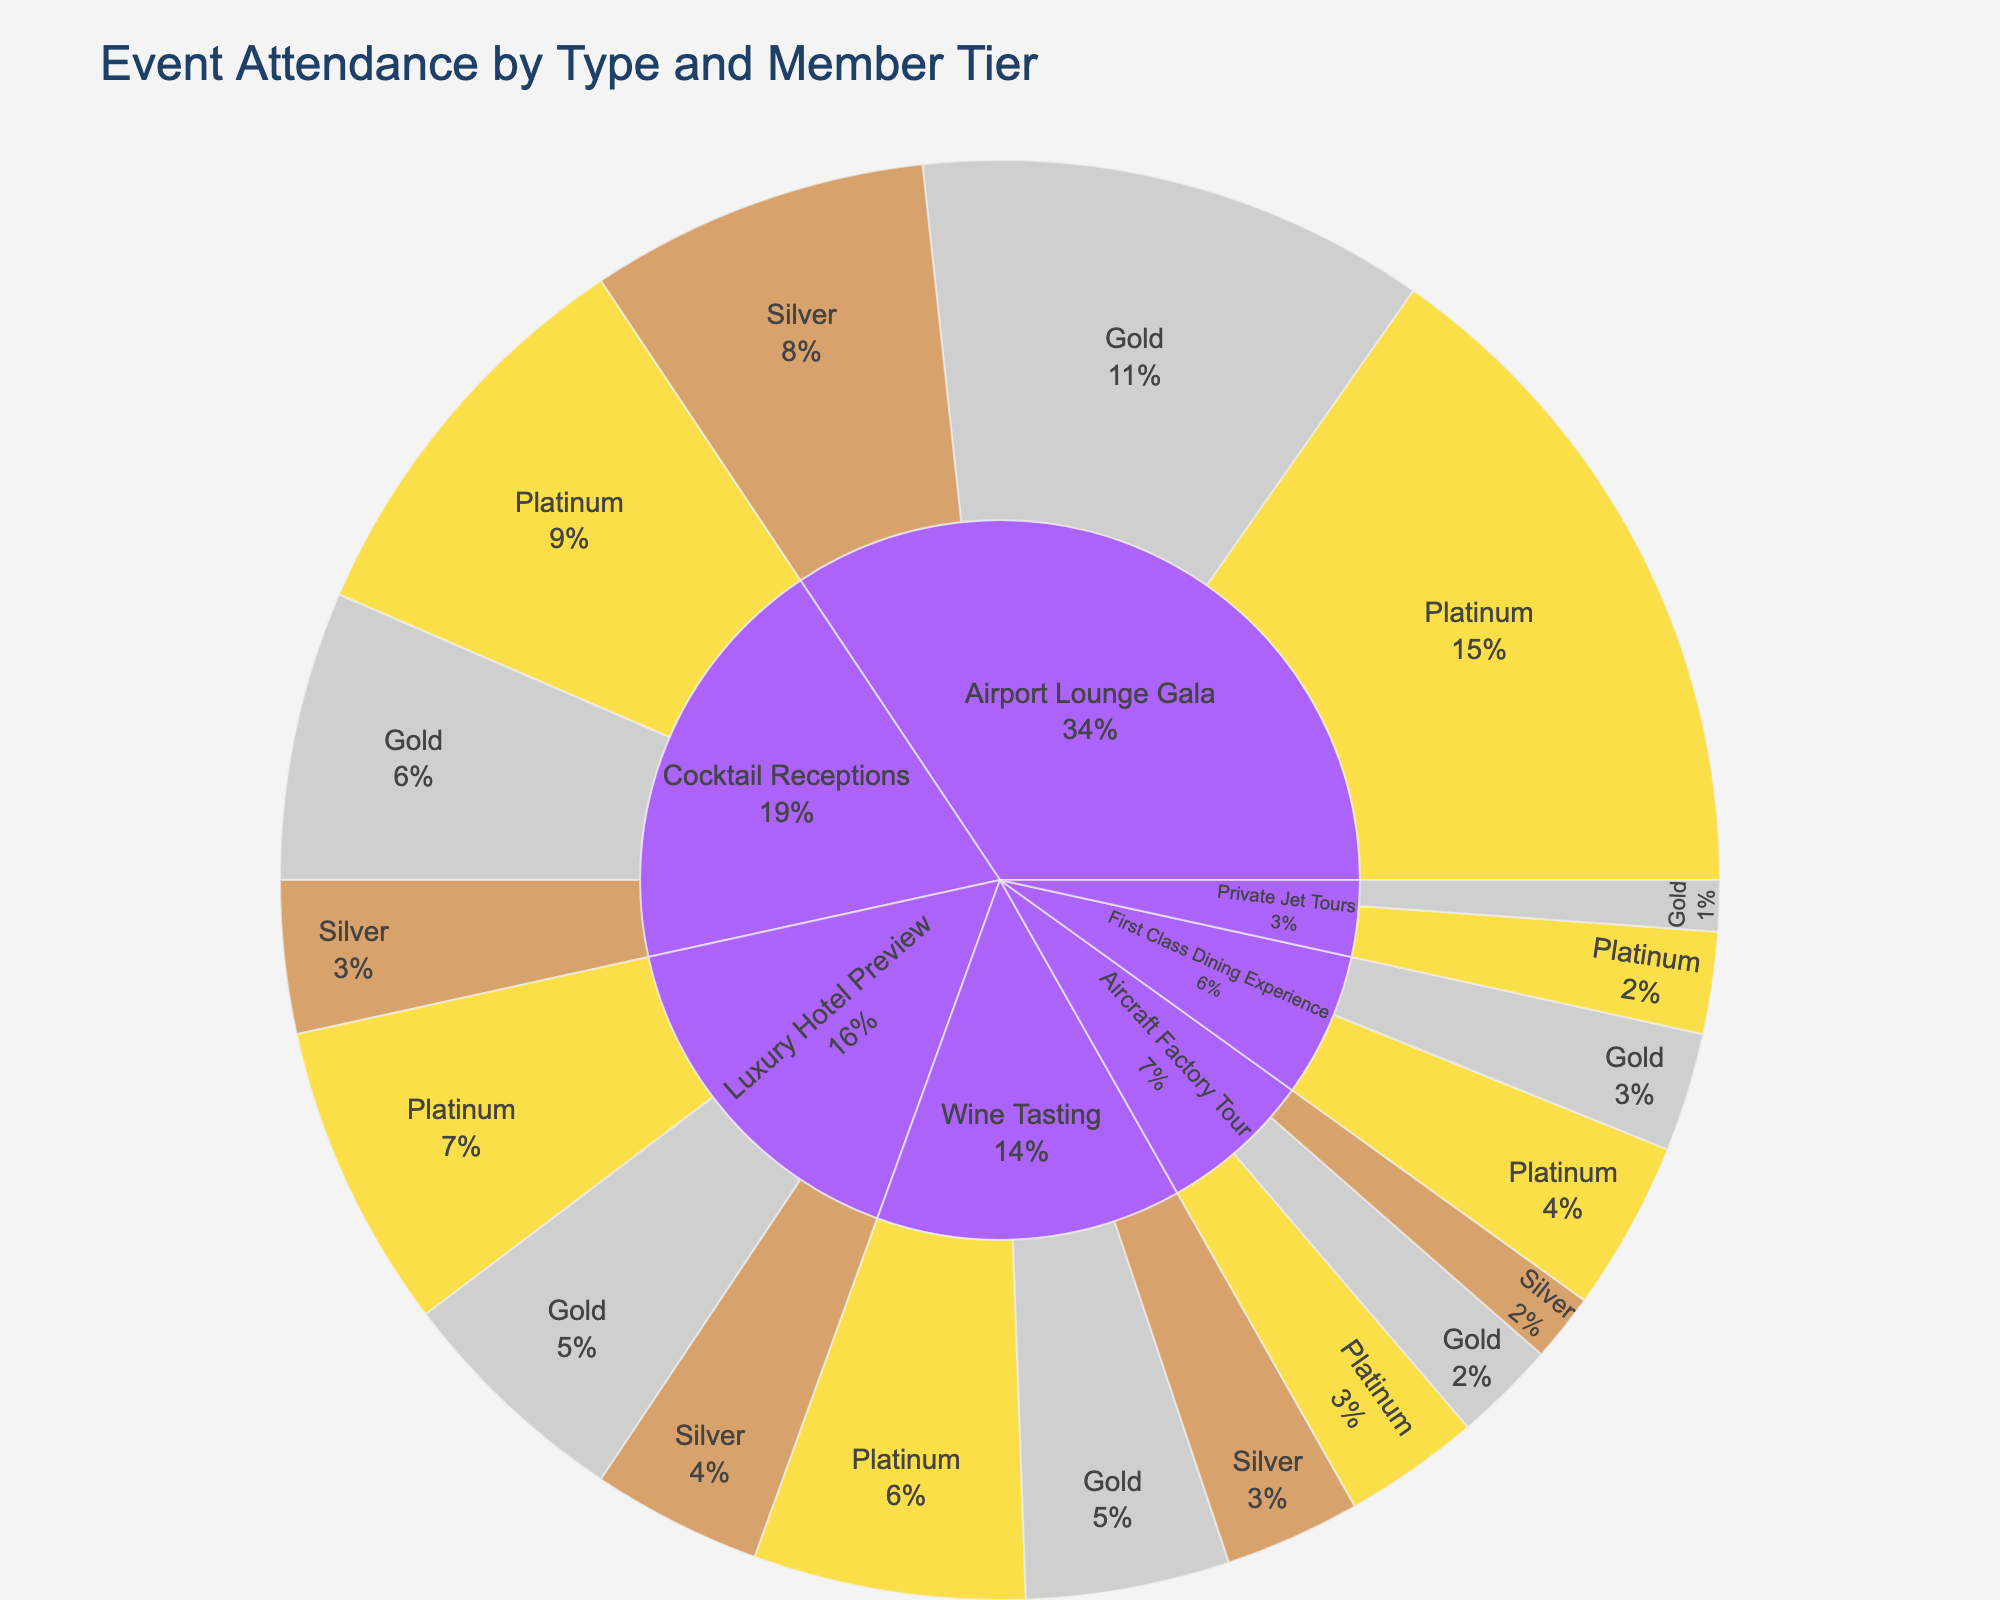What's the title of the plot? The title is displayed at the top of the figure. It reads "Event Attendance by Type and Member Tier".
Answer: Event Attendance by Type and Member Tier Which event type has the highest attendance for Platinum members? The innermost ring represents the event type, and the next ring indicates the member tier along with the respective attendance. "Airport Lounge Gala" has the largest segment in the Platinum tier.
Answer: Airport Lounge Gala What is the total attendance for Wine Tasting? Sum the attendance values of all member tiers under the "Wine Tasting" segment: 80 (Platinum) + 60 (Gold) + 40 (Silver) = 180.
Answer: 180 How does the attendance for "Cocktail Receptions" compare to "Aircraft Factory Tour" for Gold members? Find the segments under each event type labeled as "Gold" and compare their values: 85 (Cocktail Receptions) vs. 30 (Aircraft Factory Tour).
Answer: Cocktail Receptions has higher attendance What's the least attended event for Silver members? Look for the smallest segment within the Silver tier: "Aircraft Factory Tour" has 20 attendees.
Answer: Aircraft Factory Tour How much more attended is the "Airport Lounge Gala" than the "Private Jet Tours" for Platinum members? Subtract the attendance of Platinum in "Private Jet Tours" from the attendance in "Airport Lounge Gala": 200 - 30 = 170.
Answer: 170 What's the distribution of attendance among member tiers in "Luxury Hotel Preview"? Examine the segments under "Luxury Hotel Preview": Platinum (90), Gold (70), and Silver (50).
Answer: Platinum: 90, Gold: 70, Silver: 50 Which member tier has the overall highest attendance across all events? Sum the values of each member tier across all event types. The Platinum tier has the highest cumulative attendance across the segments.
Answer: Platinum What's the attendance difference between Gold and Silver members for "First Class Dining Experience"? Subtract the attendance of Silver members from Gold members for this event type: 35 - 0 = 35 (Silver tier isn't indicated for this event).
Answer: 35 